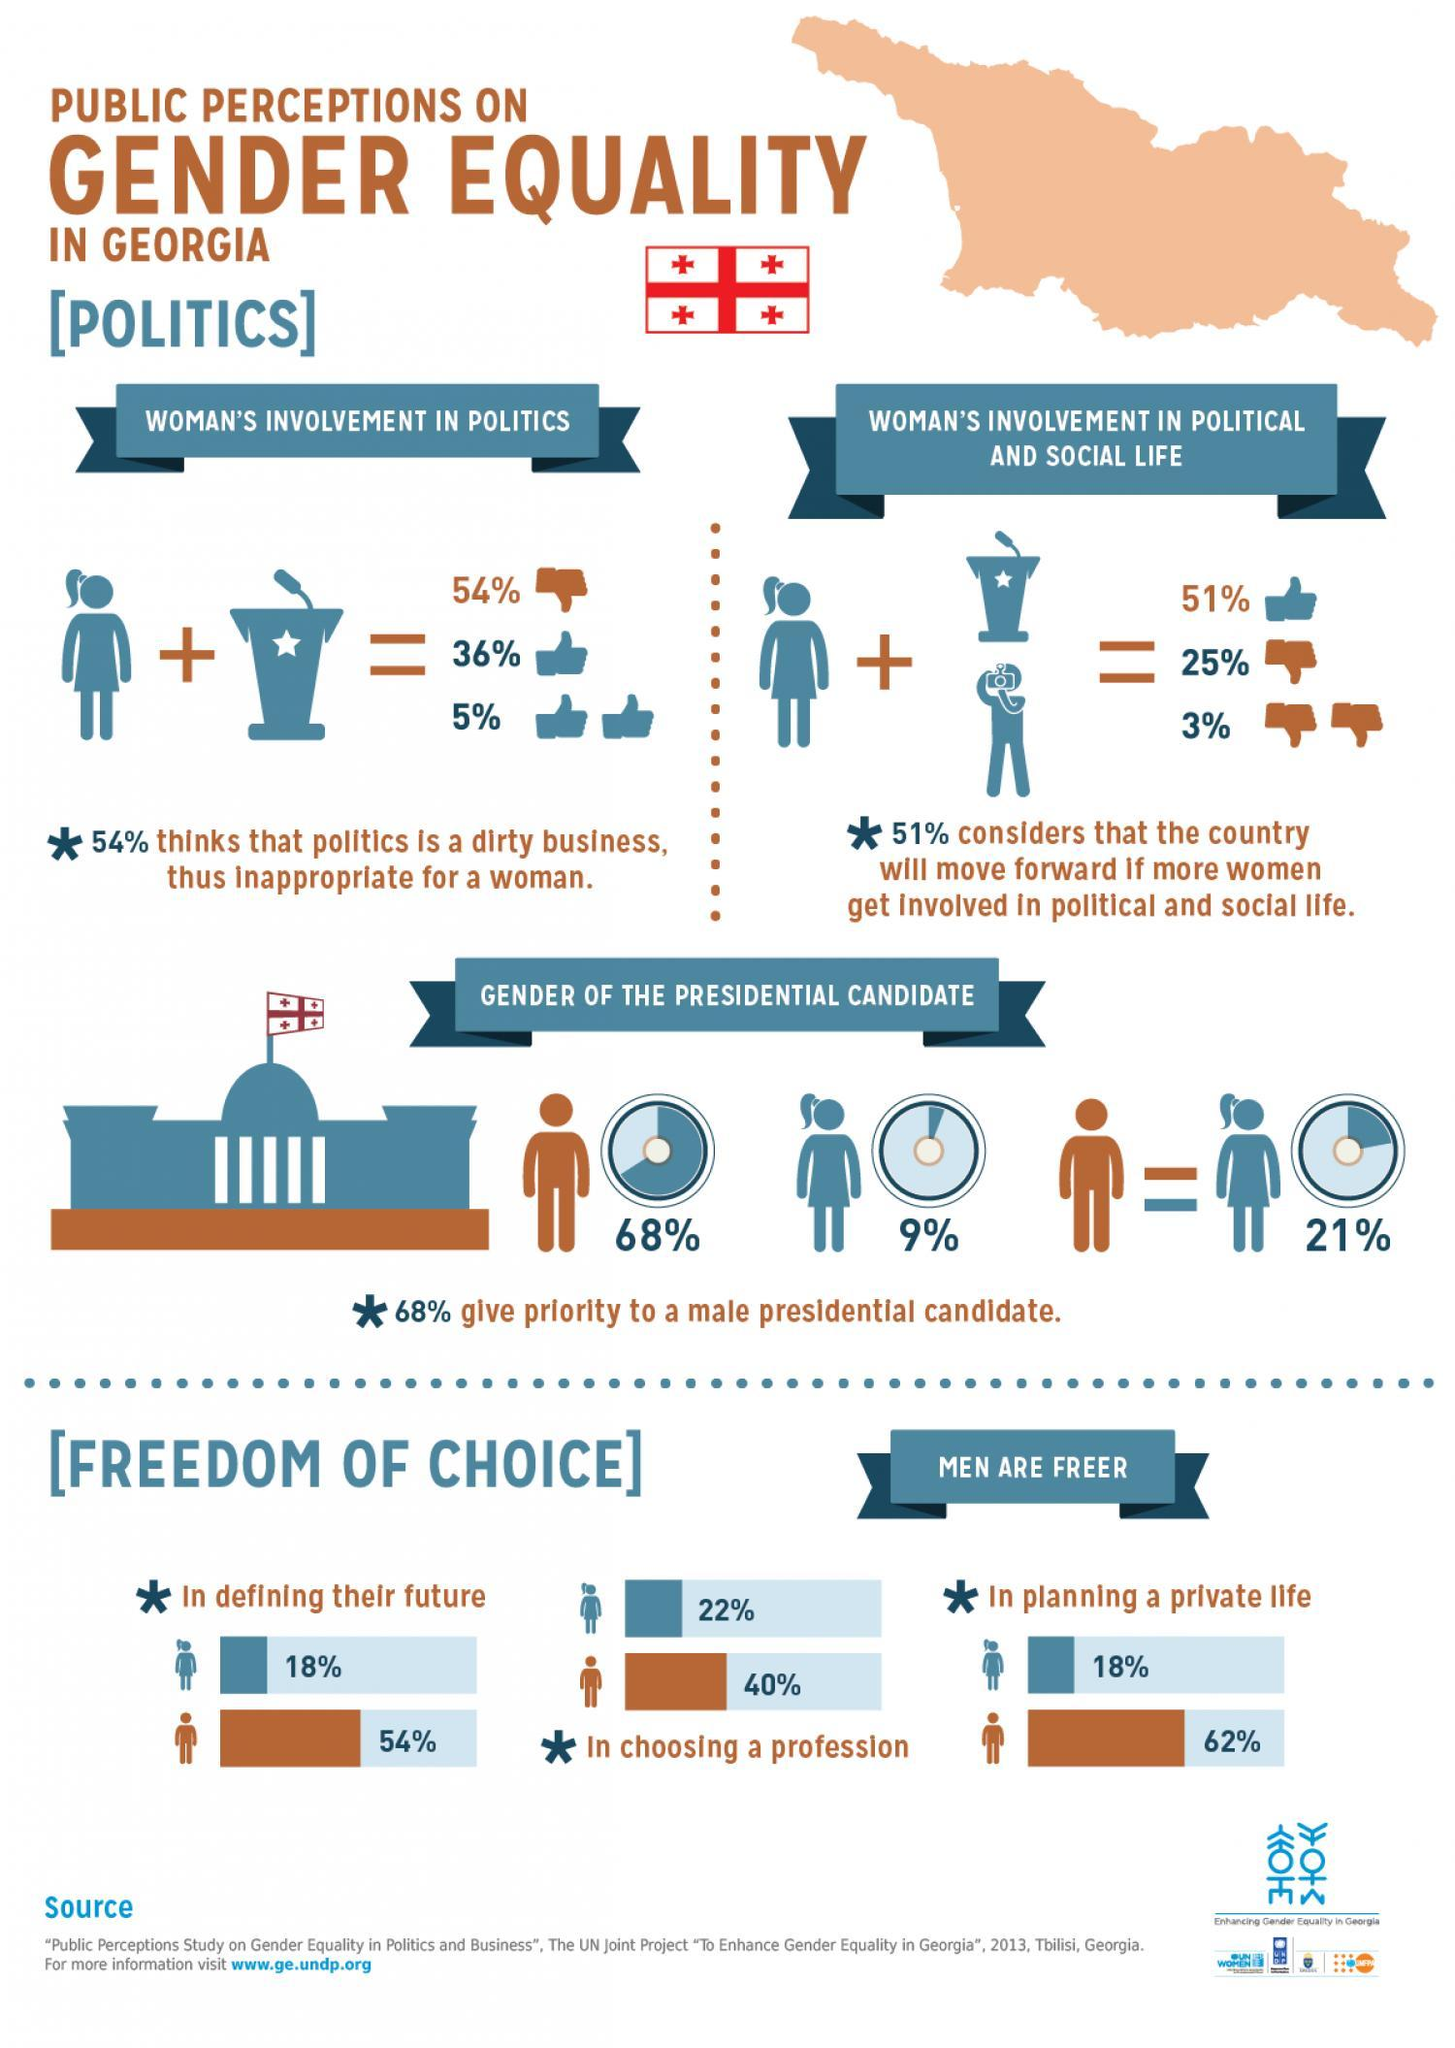What percent of women in Georgia felt free in choosing a profession?
Answer the question with a short phrase. 22% What percent of women in Georgia felt free in defining their future? 18% What percent of men in Georgia are free in planning their private life? 62% What percent of Georgians give priority to a female presidential candidate? 9% What percent of Georgians give equal priority to both male & female presidential candidates? 21% 